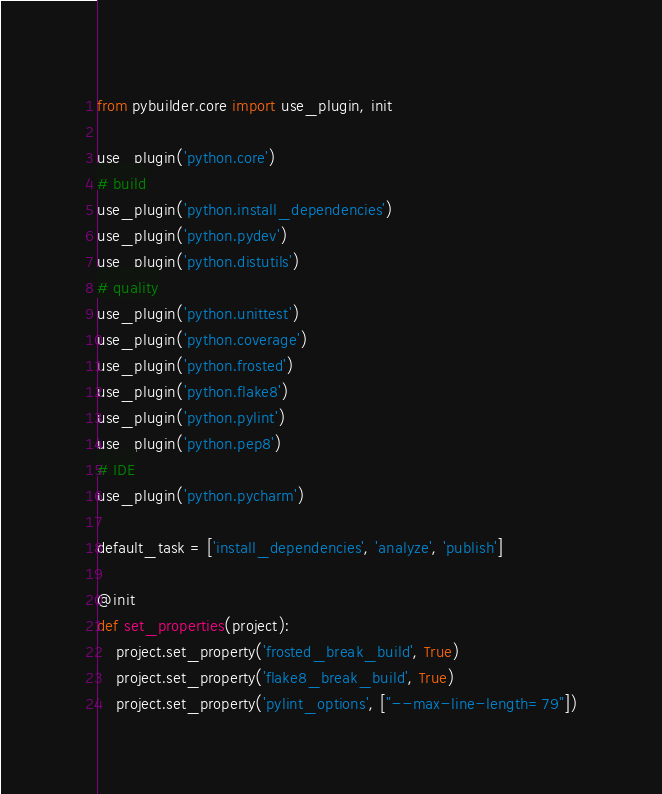<code> <loc_0><loc_0><loc_500><loc_500><_Python_>from pybuilder.core import use_plugin, init

use_plugin('python.core')
# build
use_plugin('python.install_dependencies')
use_plugin('python.pydev')
use_plugin('python.distutils')
# quality
use_plugin('python.unittest')
use_plugin('python.coverage')
use_plugin('python.frosted')
use_plugin('python.flake8')
use_plugin('python.pylint')
use_plugin('python.pep8')
# IDE
use_plugin('python.pycharm')

default_task = ['install_dependencies', 'analyze', 'publish']

@init
def set_properties(project):
    project.set_property('frosted_break_build', True)
    project.set_property('flake8_break_build', True)
    project.set_property('pylint_options', ["--max-line-length=79"])

</code> 